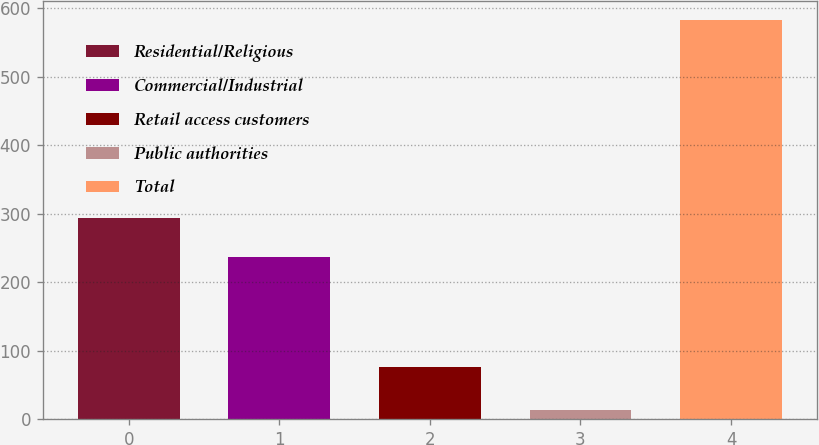Convert chart to OTSL. <chart><loc_0><loc_0><loc_500><loc_500><bar_chart><fcel>Residential/Religious<fcel>Commercial/Industrial<fcel>Retail access customers<fcel>Public authorities<fcel>Total<nl><fcel>293.8<fcel>237<fcel>76<fcel>14<fcel>582<nl></chart> 